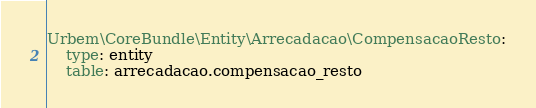Convert code to text. <code><loc_0><loc_0><loc_500><loc_500><_YAML_>Urbem\CoreBundle\Entity\Arrecadacao\CompensacaoResto:
    type: entity
    table: arrecadacao.compensacao_resto</code> 